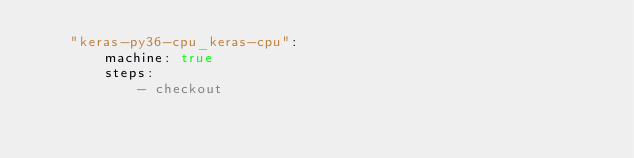<code> <loc_0><loc_0><loc_500><loc_500><_YAML_>    "keras-py36-cpu_keras-cpu":
        machine: true
        steps:
            - checkout</code> 